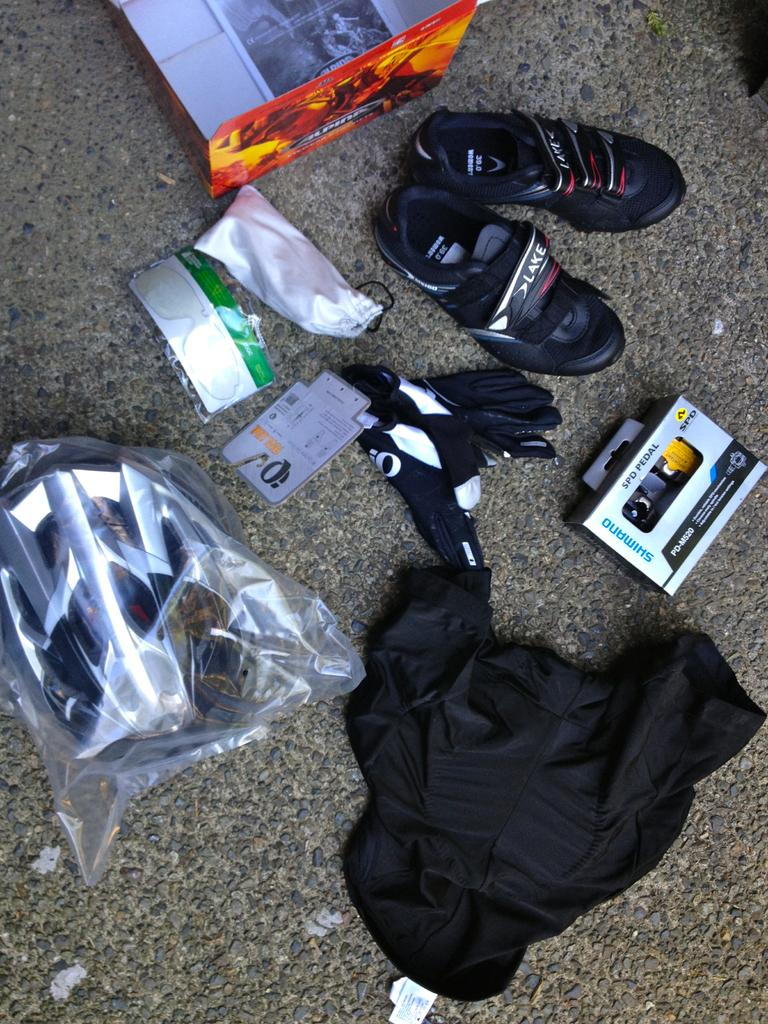What type of footwear is visible in the image? There is a pair of shoes in the image. What type of clothing is also present in the image? There are gloves in the image. What object in the image might be used for storage or packaging? There is a box in the image. What protective gear is featured in the image? There is a helmet in the image. What type of fabric is present in the image? There is a cloth in the image. What label or identifier is visible in the image? There is a tag in the image. What can be seen on the ground in the image? There are objects on the path in the image. What advice is given on the tag in the image? There is no advice present on the tag in the image; it is simply a label or identifier. What type of competition is being held in the image? There is no competition depicted in the image; it features a variety of objects and clothing items. 